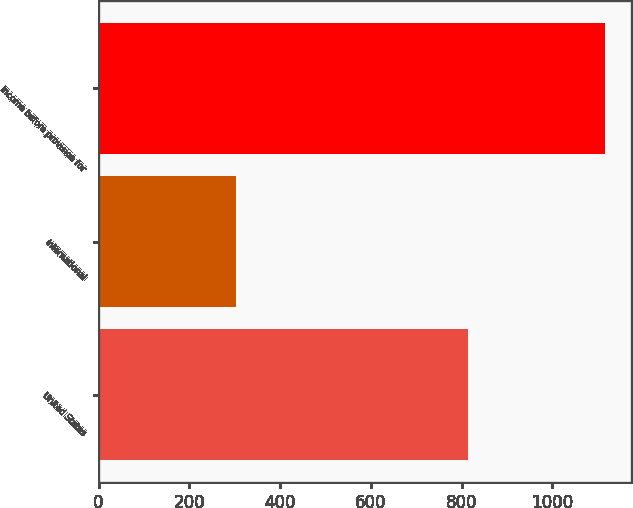<chart> <loc_0><loc_0><loc_500><loc_500><bar_chart><fcel>United States<fcel>International<fcel>Income before provision for<nl><fcel>814.7<fcel>302<fcel>1116.7<nl></chart> 